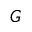Convert formula to latex. <formula><loc_0><loc_0><loc_500><loc_500>G</formula> 